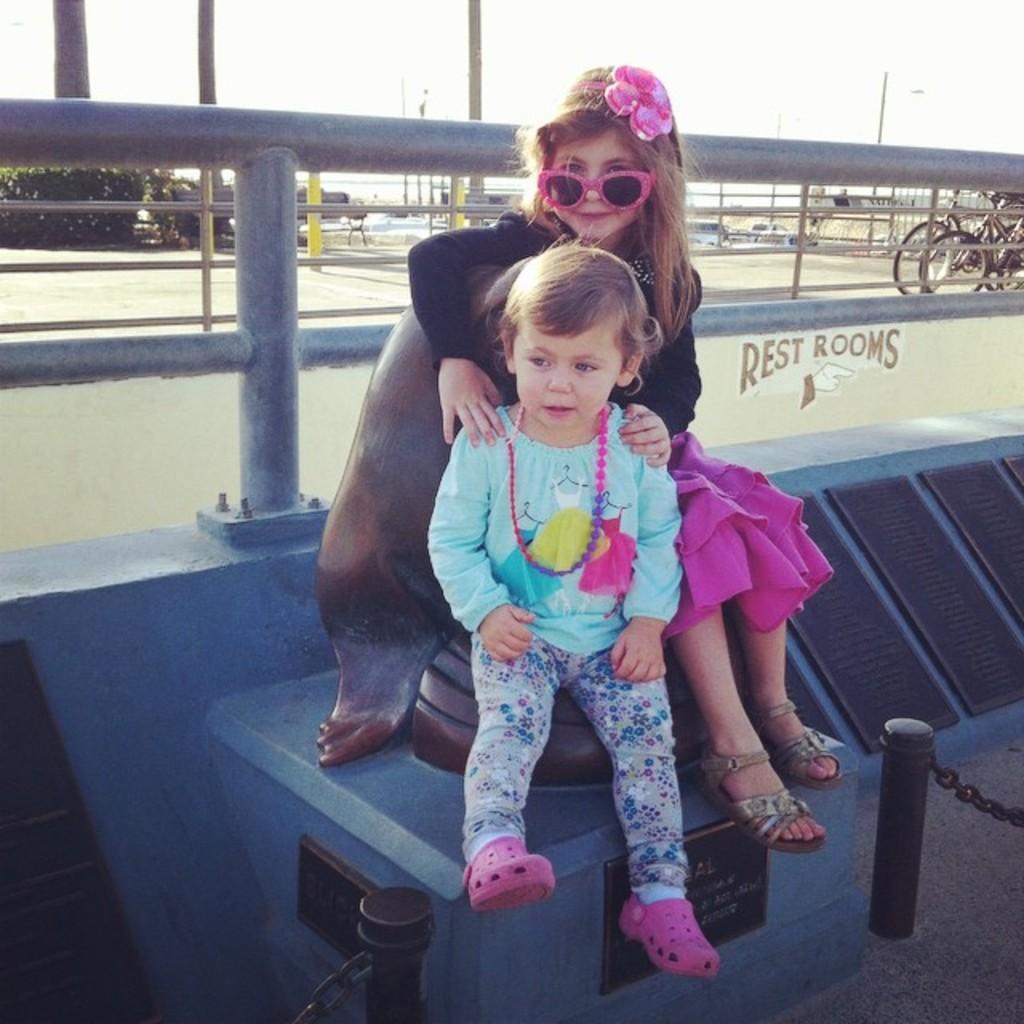How would you summarize this image in a sentence or two? In this image we can see two children sitting. On the backside we can see a fence, bicycles, poles, plants and the sky which looks cloudy. 